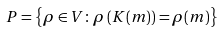Convert formula to latex. <formula><loc_0><loc_0><loc_500><loc_500>P = \left \{ \rho \in V \colon \rho \left ( K ( m ) \right ) = \rho ( m ) \right \}</formula> 